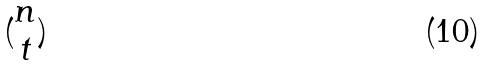Convert formula to latex. <formula><loc_0><loc_0><loc_500><loc_500>( \begin{matrix} n \\ t \end{matrix} )</formula> 